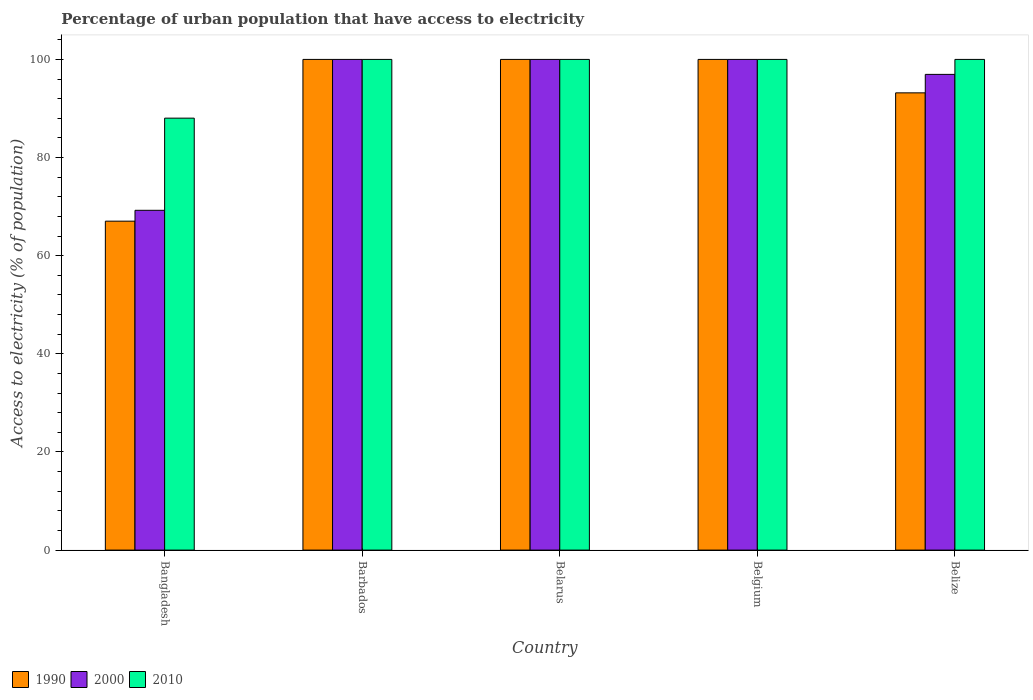How many different coloured bars are there?
Keep it short and to the point. 3. How many groups of bars are there?
Offer a terse response. 5. Are the number of bars per tick equal to the number of legend labels?
Provide a short and direct response. Yes. Are the number of bars on each tick of the X-axis equal?
Offer a very short reply. Yes. How many bars are there on the 5th tick from the left?
Ensure brevity in your answer.  3. How many bars are there on the 4th tick from the right?
Ensure brevity in your answer.  3. What is the label of the 2nd group of bars from the left?
Provide a short and direct response. Barbados. What is the percentage of urban population that have access to electricity in 1990 in Belize?
Ensure brevity in your answer.  93.19. Across all countries, what is the maximum percentage of urban population that have access to electricity in 1990?
Ensure brevity in your answer.  100. Across all countries, what is the minimum percentage of urban population that have access to electricity in 2010?
Your response must be concise. 88.03. In which country was the percentage of urban population that have access to electricity in 2010 maximum?
Offer a very short reply. Barbados. What is the total percentage of urban population that have access to electricity in 2010 in the graph?
Ensure brevity in your answer.  488.03. What is the difference between the percentage of urban population that have access to electricity in 2010 in Bangladesh and that in Barbados?
Make the answer very short. -11.97. What is the difference between the percentage of urban population that have access to electricity in 2000 in Belize and the percentage of urban population that have access to electricity in 2010 in Bangladesh?
Your answer should be compact. 8.92. What is the average percentage of urban population that have access to electricity in 1990 per country?
Ensure brevity in your answer.  92.04. In how many countries, is the percentage of urban population that have access to electricity in 2000 greater than 16 %?
Offer a terse response. 5. What is the ratio of the percentage of urban population that have access to electricity in 2010 in Belarus to that in Belize?
Provide a succinct answer. 1. Is the percentage of urban population that have access to electricity in 2000 in Belgium less than that in Belize?
Your answer should be very brief. No. Is the difference between the percentage of urban population that have access to electricity in 2010 in Barbados and Belarus greater than the difference between the percentage of urban population that have access to electricity in 2000 in Barbados and Belarus?
Offer a very short reply. No. What is the difference between the highest and the lowest percentage of urban population that have access to electricity in 2000?
Provide a short and direct response. 30.75. What does the 1st bar from the left in Belize represents?
Give a very brief answer. 1990. What does the 2nd bar from the right in Belgium represents?
Provide a short and direct response. 2000. Is it the case that in every country, the sum of the percentage of urban population that have access to electricity in 2000 and percentage of urban population that have access to electricity in 1990 is greater than the percentage of urban population that have access to electricity in 2010?
Keep it short and to the point. Yes. Are all the bars in the graph horizontal?
Offer a very short reply. No. How many countries are there in the graph?
Keep it short and to the point. 5. What is the difference between two consecutive major ticks on the Y-axis?
Offer a terse response. 20. Does the graph contain grids?
Provide a short and direct response. No. Where does the legend appear in the graph?
Make the answer very short. Bottom left. How many legend labels are there?
Give a very brief answer. 3. What is the title of the graph?
Keep it short and to the point. Percentage of urban population that have access to electricity. Does "1999" appear as one of the legend labels in the graph?
Offer a very short reply. No. What is the label or title of the X-axis?
Your response must be concise. Country. What is the label or title of the Y-axis?
Your response must be concise. Access to electricity (% of population). What is the Access to electricity (% of population) in 1990 in Bangladesh?
Your answer should be very brief. 67.04. What is the Access to electricity (% of population) in 2000 in Bangladesh?
Your answer should be compact. 69.25. What is the Access to electricity (% of population) of 2010 in Bangladesh?
Your answer should be compact. 88.03. What is the Access to electricity (% of population) in 2000 in Barbados?
Ensure brevity in your answer.  100. What is the Access to electricity (% of population) in 2000 in Belarus?
Provide a succinct answer. 100. What is the Access to electricity (% of population) of 1990 in Belize?
Offer a very short reply. 93.19. What is the Access to electricity (% of population) in 2000 in Belize?
Provide a short and direct response. 96.95. What is the Access to electricity (% of population) of 2010 in Belize?
Provide a short and direct response. 100. Across all countries, what is the maximum Access to electricity (% of population) of 2010?
Provide a short and direct response. 100. Across all countries, what is the minimum Access to electricity (% of population) of 1990?
Provide a succinct answer. 67.04. Across all countries, what is the minimum Access to electricity (% of population) of 2000?
Offer a terse response. 69.25. Across all countries, what is the minimum Access to electricity (% of population) in 2010?
Offer a terse response. 88.03. What is the total Access to electricity (% of population) of 1990 in the graph?
Provide a short and direct response. 460.22. What is the total Access to electricity (% of population) in 2000 in the graph?
Offer a very short reply. 466.2. What is the total Access to electricity (% of population) of 2010 in the graph?
Your response must be concise. 488.03. What is the difference between the Access to electricity (% of population) of 1990 in Bangladesh and that in Barbados?
Provide a succinct answer. -32.96. What is the difference between the Access to electricity (% of population) in 2000 in Bangladesh and that in Barbados?
Give a very brief answer. -30.75. What is the difference between the Access to electricity (% of population) of 2010 in Bangladesh and that in Barbados?
Your answer should be very brief. -11.97. What is the difference between the Access to electricity (% of population) in 1990 in Bangladesh and that in Belarus?
Offer a terse response. -32.96. What is the difference between the Access to electricity (% of population) in 2000 in Bangladesh and that in Belarus?
Provide a succinct answer. -30.75. What is the difference between the Access to electricity (% of population) in 2010 in Bangladesh and that in Belarus?
Ensure brevity in your answer.  -11.97. What is the difference between the Access to electricity (% of population) of 1990 in Bangladesh and that in Belgium?
Your answer should be very brief. -32.96. What is the difference between the Access to electricity (% of population) in 2000 in Bangladesh and that in Belgium?
Your response must be concise. -30.75. What is the difference between the Access to electricity (% of population) in 2010 in Bangladesh and that in Belgium?
Keep it short and to the point. -11.97. What is the difference between the Access to electricity (% of population) of 1990 in Bangladesh and that in Belize?
Offer a terse response. -26.15. What is the difference between the Access to electricity (% of population) of 2000 in Bangladesh and that in Belize?
Make the answer very short. -27.7. What is the difference between the Access to electricity (% of population) in 2010 in Bangladesh and that in Belize?
Your response must be concise. -11.97. What is the difference between the Access to electricity (% of population) of 1990 in Barbados and that in Belarus?
Offer a very short reply. 0. What is the difference between the Access to electricity (% of population) of 2000 in Barbados and that in Belarus?
Offer a very short reply. 0. What is the difference between the Access to electricity (% of population) of 2010 in Barbados and that in Belarus?
Offer a terse response. 0. What is the difference between the Access to electricity (% of population) of 1990 in Barbados and that in Belize?
Your answer should be compact. 6.81. What is the difference between the Access to electricity (% of population) of 2000 in Barbados and that in Belize?
Your answer should be very brief. 3.05. What is the difference between the Access to electricity (% of population) of 1990 in Belarus and that in Belgium?
Make the answer very short. 0. What is the difference between the Access to electricity (% of population) in 2000 in Belarus and that in Belgium?
Give a very brief answer. 0. What is the difference between the Access to electricity (% of population) of 2010 in Belarus and that in Belgium?
Make the answer very short. 0. What is the difference between the Access to electricity (% of population) in 1990 in Belarus and that in Belize?
Offer a very short reply. 6.81. What is the difference between the Access to electricity (% of population) of 2000 in Belarus and that in Belize?
Your answer should be very brief. 3.05. What is the difference between the Access to electricity (% of population) of 2010 in Belarus and that in Belize?
Provide a short and direct response. 0. What is the difference between the Access to electricity (% of population) of 1990 in Belgium and that in Belize?
Offer a terse response. 6.81. What is the difference between the Access to electricity (% of population) of 2000 in Belgium and that in Belize?
Keep it short and to the point. 3.05. What is the difference between the Access to electricity (% of population) in 2010 in Belgium and that in Belize?
Your answer should be compact. 0. What is the difference between the Access to electricity (% of population) of 1990 in Bangladesh and the Access to electricity (% of population) of 2000 in Barbados?
Provide a short and direct response. -32.96. What is the difference between the Access to electricity (% of population) in 1990 in Bangladesh and the Access to electricity (% of population) in 2010 in Barbados?
Your answer should be very brief. -32.96. What is the difference between the Access to electricity (% of population) in 2000 in Bangladesh and the Access to electricity (% of population) in 2010 in Barbados?
Ensure brevity in your answer.  -30.75. What is the difference between the Access to electricity (% of population) of 1990 in Bangladesh and the Access to electricity (% of population) of 2000 in Belarus?
Provide a succinct answer. -32.96. What is the difference between the Access to electricity (% of population) in 1990 in Bangladesh and the Access to electricity (% of population) in 2010 in Belarus?
Keep it short and to the point. -32.96. What is the difference between the Access to electricity (% of population) in 2000 in Bangladesh and the Access to electricity (% of population) in 2010 in Belarus?
Give a very brief answer. -30.75. What is the difference between the Access to electricity (% of population) of 1990 in Bangladesh and the Access to electricity (% of population) of 2000 in Belgium?
Make the answer very short. -32.96. What is the difference between the Access to electricity (% of population) of 1990 in Bangladesh and the Access to electricity (% of population) of 2010 in Belgium?
Ensure brevity in your answer.  -32.96. What is the difference between the Access to electricity (% of population) in 2000 in Bangladesh and the Access to electricity (% of population) in 2010 in Belgium?
Your response must be concise. -30.75. What is the difference between the Access to electricity (% of population) in 1990 in Bangladesh and the Access to electricity (% of population) in 2000 in Belize?
Provide a short and direct response. -29.91. What is the difference between the Access to electricity (% of population) of 1990 in Bangladesh and the Access to electricity (% of population) of 2010 in Belize?
Your response must be concise. -32.96. What is the difference between the Access to electricity (% of population) in 2000 in Bangladesh and the Access to electricity (% of population) in 2010 in Belize?
Keep it short and to the point. -30.75. What is the difference between the Access to electricity (% of population) of 1990 in Barbados and the Access to electricity (% of population) of 2000 in Belarus?
Provide a short and direct response. 0. What is the difference between the Access to electricity (% of population) in 1990 in Barbados and the Access to electricity (% of population) in 2000 in Belgium?
Ensure brevity in your answer.  0. What is the difference between the Access to electricity (% of population) of 1990 in Barbados and the Access to electricity (% of population) of 2010 in Belgium?
Provide a succinct answer. 0. What is the difference between the Access to electricity (% of population) of 1990 in Barbados and the Access to electricity (% of population) of 2000 in Belize?
Provide a short and direct response. 3.05. What is the difference between the Access to electricity (% of population) in 2000 in Barbados and the Access to electricity (% of population) in 2010 in Belize?
Give a very brief answer. 0. What is the difference between the Access to electricity (% of population) of 1990 in Belarus and the Access to electricity (% of population) of 2000 in Belize?
Your answer should be compact. 3.05. What is the difference between the Access to electricity (% of population) of 1990 in Belarus and the Access to electricity (% of population) of 2010 in Belize?
Your answer should be compact. 0. What is the difference between the Access to electricity (% of population) in 2000 in Belarus and the Access to electricity (% of population) in 2010 in Belize?
Give a very brief answer. 0. What is the difference between the Access to electricity (% of population) in 1990 in Belgium and the Access to electricity (% of population) in 2000 in Belize?
Your response must be concise. 3.05. What is the difference between the Access to electricity (% of population) in 1990 in Belgium and the Access to electricity (% of population) in 2010 in Belize?
Offer a very short reply. 0. What is the average Access to electricity (% of population) in 1990 per country?
Make the answer very short. 92.04. What is the average Access to electricity (% of population) in 2000 per country?
Your answer should be very brief. 93.24. What is the average Access to electricity (% of population) of 2010 per country?
Make the answer very short. 97.61. What is the difference between the Access to electricity (% of population) in 1990 and Access to electricity (% of population) in 2000 in Bangladesh?
Keep it short and to the point. -2.21. What is the difference between the Access to electricity (% of population) in 1990 and Access to electricity (% of population) in 2010 in Bangladesh?
Provide a short and direct response. -20.99. What is the difference between the Access to electricity (% of population) in 2000 and Access to electricity (% of population) in 2010 in Bangladesh?
Your answer should be compact. -18.78. What is the difference between the Access to electricity (% of population) in 1990 and Access to electricity (% of population) in 2000 in Barbados?
Ensure brevity in your answer.  0. What is the difference between the Access to electricity (% of population) of 1990 and Access to electricity (% of population) of 2010 in Barbados?
Ensure brevity in your answer.  0. What is the difference between the Access to electricity (% of population) of 2000 and Access to electricity (% of population) of 2010 in Barbados?
Your answer should be very brief. 0. What is the difference between the Access to electricity (% of population) of 1990 and Access to electricity (% of population) of 2010 in Belgium?
Your response must be concise. 0. What is the difference between the Access to electricity (% of population) of 1990 and Access to electricity (% of population) of 2000 in Belize?
Offer a terse response. -3.76. What is the difference between the Access to electricity (% of population) in 1990 and Access to electricity (% of population) in 2010 in Belize?
Offer a very short reply. -6.81. What is the difference between the Access to electricity (% of population) in 2000 and Access to electricity (% of population) in 2010 in Belize?
Give a very brief answer. -3.05. What is the ratio of the Access to electricity (% of population) in 1990 in Bangladesh to that in Barbados?
Offer a very short reply. 0.67. What is the ratio of the Access to electricity (% of population) of 2000 in Bangladesh to that in Barbados?
Offer a very short reply. 0.69. What is the ratio of the Access to electricity (% of population) of 2010 in Bangladesh to that in Barbados?
Offer a very short reply. 0.88. What is the ratio of the Access to electricity (% of population) of 1990 in Bangladesh to that in Belarus?
Your answer should be very brief. 0.67. What is the ratio of the Access to electricity (% of population) of 2000 in Bangladesh to that in Belarus?
Provide a succinct answer. 0.69. What is the ratio of the Access to electricity (% of population) in 2010 in Bangladesh to that in Belarus?
Provide a short and direct response. 0.88. What is the ratio of the Access to electricity (% of population) of 1990 in Bangladesh to that in Belgium?
Give a very brief answer. 0.67. What is the ratio of the Access to electricity (% of population) in 2000 in Bangladesh to that in Belgium?
Your answer should be very brief. 0.69. What is the ratio of the Access to electricity (% of population) of 2010 in Bangladesh to that in Belgium?
Provide a short and direct response. 0.88. What is the ratio of the Access to electricity (% of population) in 1990 in Bangladesh to that in Belize?
Offer a terse response. 0.72. What is the ratio of the Access to electricity (% of population) of 2000 in Bangladesh to that in Belize?
Keep it short and to the point. 0.71. What is the ratio of the Access to electricity (% of population) of 2010 in Bangladesh to that in Belize?
Keep it short and to the point. 0.88. What is the ratio of the Access to electricity (% of population) of 2000 in Barbados to that in Belarus?
Make the answer very short. 1. What is the ratio of the Access to electricity (% of population) in 2010 in Barbados to that in Belarus?
Your response must be concise. 1. What is the ratio of the Access to electricity (% of population) of 1990 in Barbados to that in Belgium?
Ensure brevity in your answer.  1. What is the ratio of the Access to electricity (% of population) in 2000 in Barbados to that in Belgium?
Your answer should be compact. 1. What is the ratio of the Access to electricity (% of population) of 1990 in Barbados to that in Belize?
Your response must be concise. 1.07. What is the ratio of the Access to electricity (% of population) in 2000 in Barbados to that in Belize?
Your answer should be very brief. 1.03. What is the ratio of the Access to electricity (% of population) in 2000 in Belarus to that in Belgium?
Ensure brevity in your answer.  1. What is the ratio of the Access to electricity (% of population) in 1990 in Belarus to that in Belize?
Provide a succinct answer. 1.07. What is the ratio of the Access to electricity (% of population) of 2000 in Belarus to that in Belize?
Offer a very short reply. 1.03. What is the ratio of the Access to electricity (% of population) in 2010 in Belarus to that in Belize?
Keep it short and to the point. 1. What is the ratio of the Access to electricity (% of population) of 1990 in Belgium to that in Belize?
Keep it short and to the point. 1.07. What is the ratio of the Access to electricity (% of population) of 2000 in Belgium to that in Belize?
Ensure brevity in your answer.  1.03. What is the ratio of the Access to electricity (% of population) in 2010 in Belgium to that in Belize?
Your answer should be compact. 1. What is the difference between the highest and the second highest Access to electricity (% of population) in 2010?
Make the answer very short. 0. What is the difference between the highest and the lowest Access to electricity (% of population) of 1990?
Give a very brief answer. 32.96. What is the difference between the highest and the lowest Access to electricity (% of population) of 2000?
Your response must be concise. 30.75. What is the difference between the highest and the lowest Access to electricity (% of population) in 2010?
Offer a terse response. 11.97. 